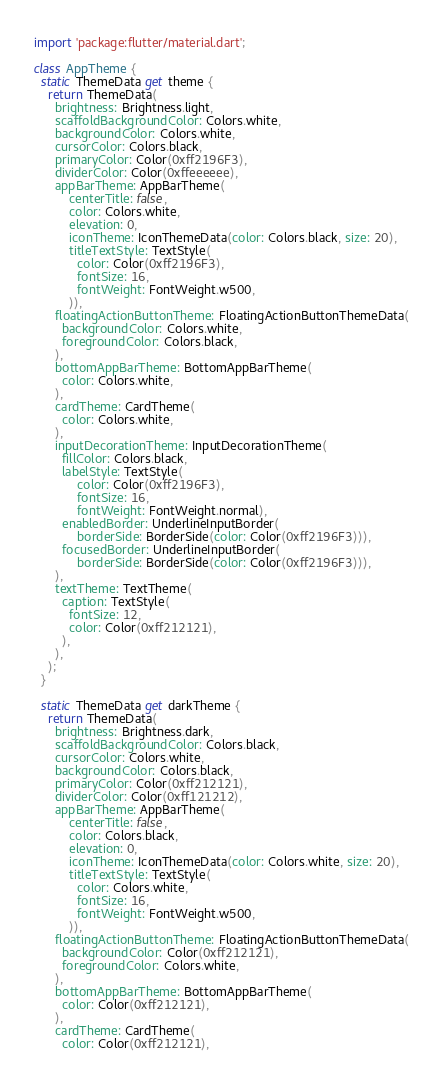<code> <loc_0><loc_0><loc_500><loc_500><_Dart_>import 'package:flutter/material.dart';

class AppTheme {
  static ThemeData get theme {
    return ThemeData(
      brightness: Brightness.light,
      scaffoldBackgroundColor: Colors.white,
      backgroundColor: Colors.white,
      cursorColor: Colors.black,
      primaryColor: Color(0xff2196F3),
      dividerColor: Color(0xffeeeeee),
      appBarTheme: AppBarTheme(
          centerTitle: false,
          color: Colors.white,
          elevation: 0,
          iconTheme: IconThemeData(color: Colors.black, size: 20),
          titleTextStyle: TextStyle(
            color: Color(0xff2196F3),
            fontSize: 16,
            fontWeight: FontWeight.w500,
          )),
      floatingActionButtonTheme: FloatingActionButtonThemeData(
        backgroundColor: Colors.white,
        foregroundColor: Colors.black,
      ),
      bottomAppBarTheme: BottomAppBarTheme(
        color: Colors.white,
      ),
      cardTheme: CardTheme(
        color: Colors.white,
      ),
      inputDecorationTheme: InputDecorationTheme(
        fillColor: Colors.black,
        labelStyle: TextStyle(
            color: Color(0xff2196F3),
            fontSize: 16,
            fontWeight: FontWeight.normal),
        enabledBorder: UnderlineInputBorder(
            borderSide: BorderSide(color: Color(0xff2196F3))),
        focusedBorder: UnderlineInputBorder(
            borderSide: BorderSide(color: Color(0xff2196F3))),
      ),
      textTheme: TextTheme(
        caption: TextStyle(
          fontSize: 12,
          color: Color(0xff212121),
        ),
      ),
    );
  }

  static ThemeData get darkTheme {
    return ThemeData(
      brightness: Brightness.dark,
      scaffoldBackgroundColor: Colors.black,
      cursorColor: Colors.white,
      backgroundColor: Colors.black,
      primaryColor: Color(0xff212121),
      dividerColor: Color(0xff121212),
      appBarTheme: AppBarTheme(
          centerTitle: false,
          color: Colors.black,
          elevation: 0,
          iconTheme: IconThemeData(color: Colors.white, size: 20),
          titleTextStyle: TextStyle(
            color: Colors.white,
            fontSize: 16,
            fontWeight: FontWeight.w500,
          )),
      floatingActionButtonTheme: FloatingActionButtonThemeData(
        backgroundColor: Color(0xff212121),
        foregroundColor: Colors.white,
      ),
      bottomAppBarTheme: BottomAppBarTheme(
        color: Color(0xff212121),
      ),
      cardTheme: CardTheme(
        color: Color(0xff212121),</code> 